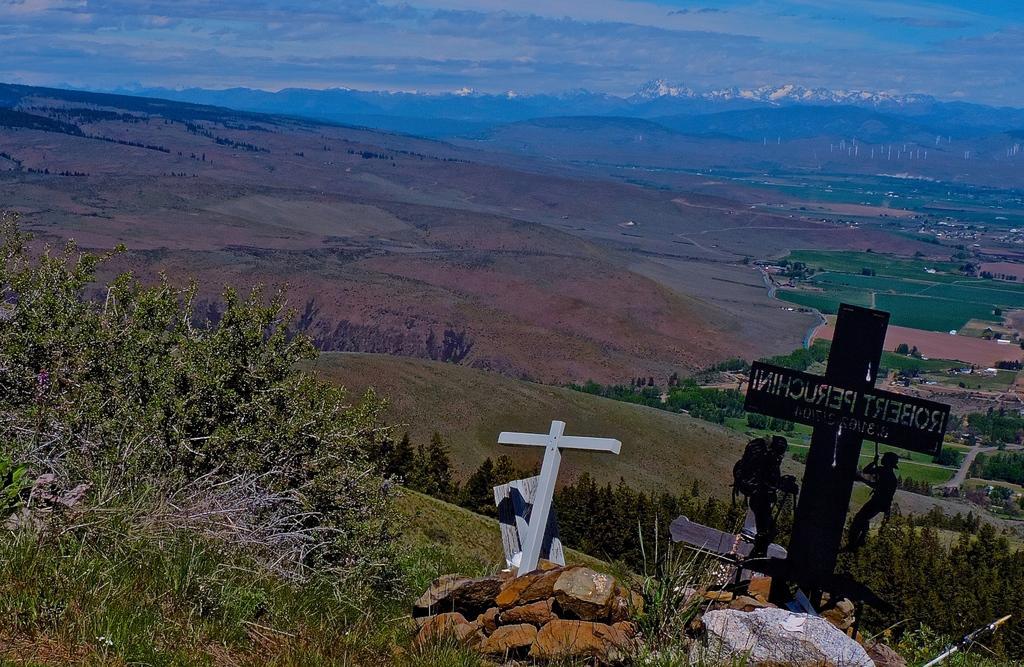Could you give a brief overview of what you see in this image? In this image I can see few stones, plants, cross symbols and the people. In the background I can see many trees, ground, clouds and the sky. 